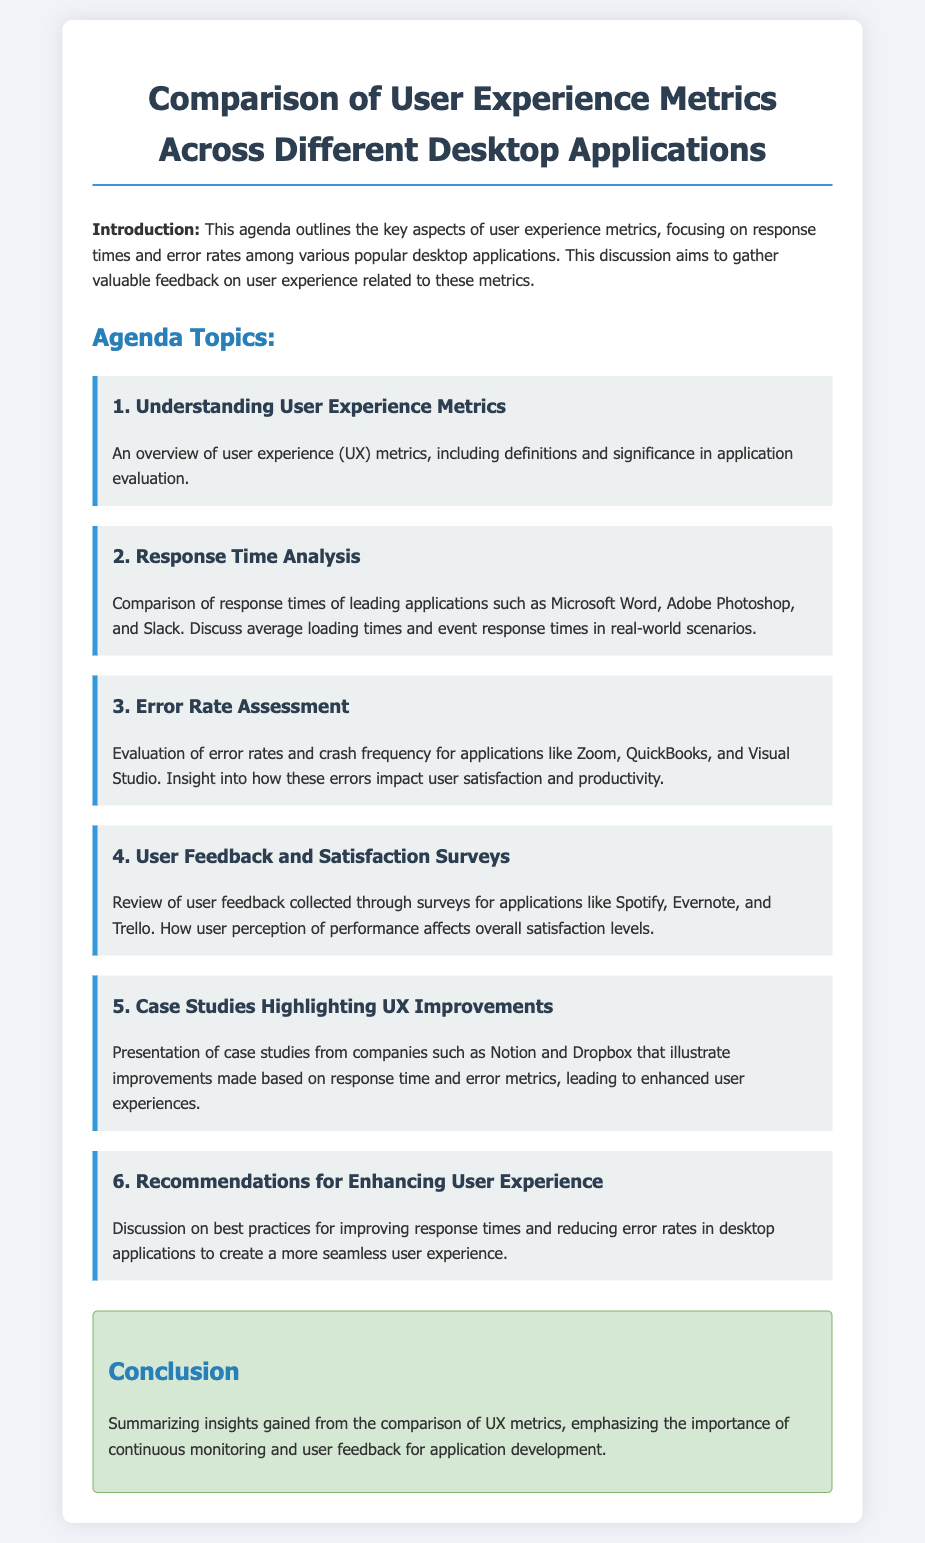What is the title of the agenda? The title is clearly stated at the top of the document, highlighting the main theme of the discussion.
Answer: Comparison of User Experience Metrics Across Different Desktop Applications What is the first topic of the agenda? The first topic introduces the concept of user experience metrics and its significance.
Answer: Understanding User Experience Metrics Which applications are compared in the response time analysis? The document lists specific applications that are being evaluated for their response times.
Answer: Microsoft Word, Adobe Photoshop, Slack What is assessed in the error rate evaluation? This part of the agenda focuses on specific applications and how errors affect user satisfaction.
Answer: Error rates and crash frequency What type of feedback is reviewed in the user feedback section? The document outlines the type of data being collected to gauge user satisfaction with certain applications.
Answer: User feedback collected through surveys Which companies are mentioned in the case studies? The case studies spotlight companies that have improved their user experience based on the discussed metrics.
Answer: Notion and Dropbox What is the final topic of the agenda? The closing topic pertains to recommendations for enhancing user experience based on the gathered insights.
Answer: Recommendations for Enhancing User Experience What is emphasized in the conclusion? The conclusion sums up the overall insights gained from the comparison of UX metrics.
Answer: Importance of continuous monitoring and user feedback 